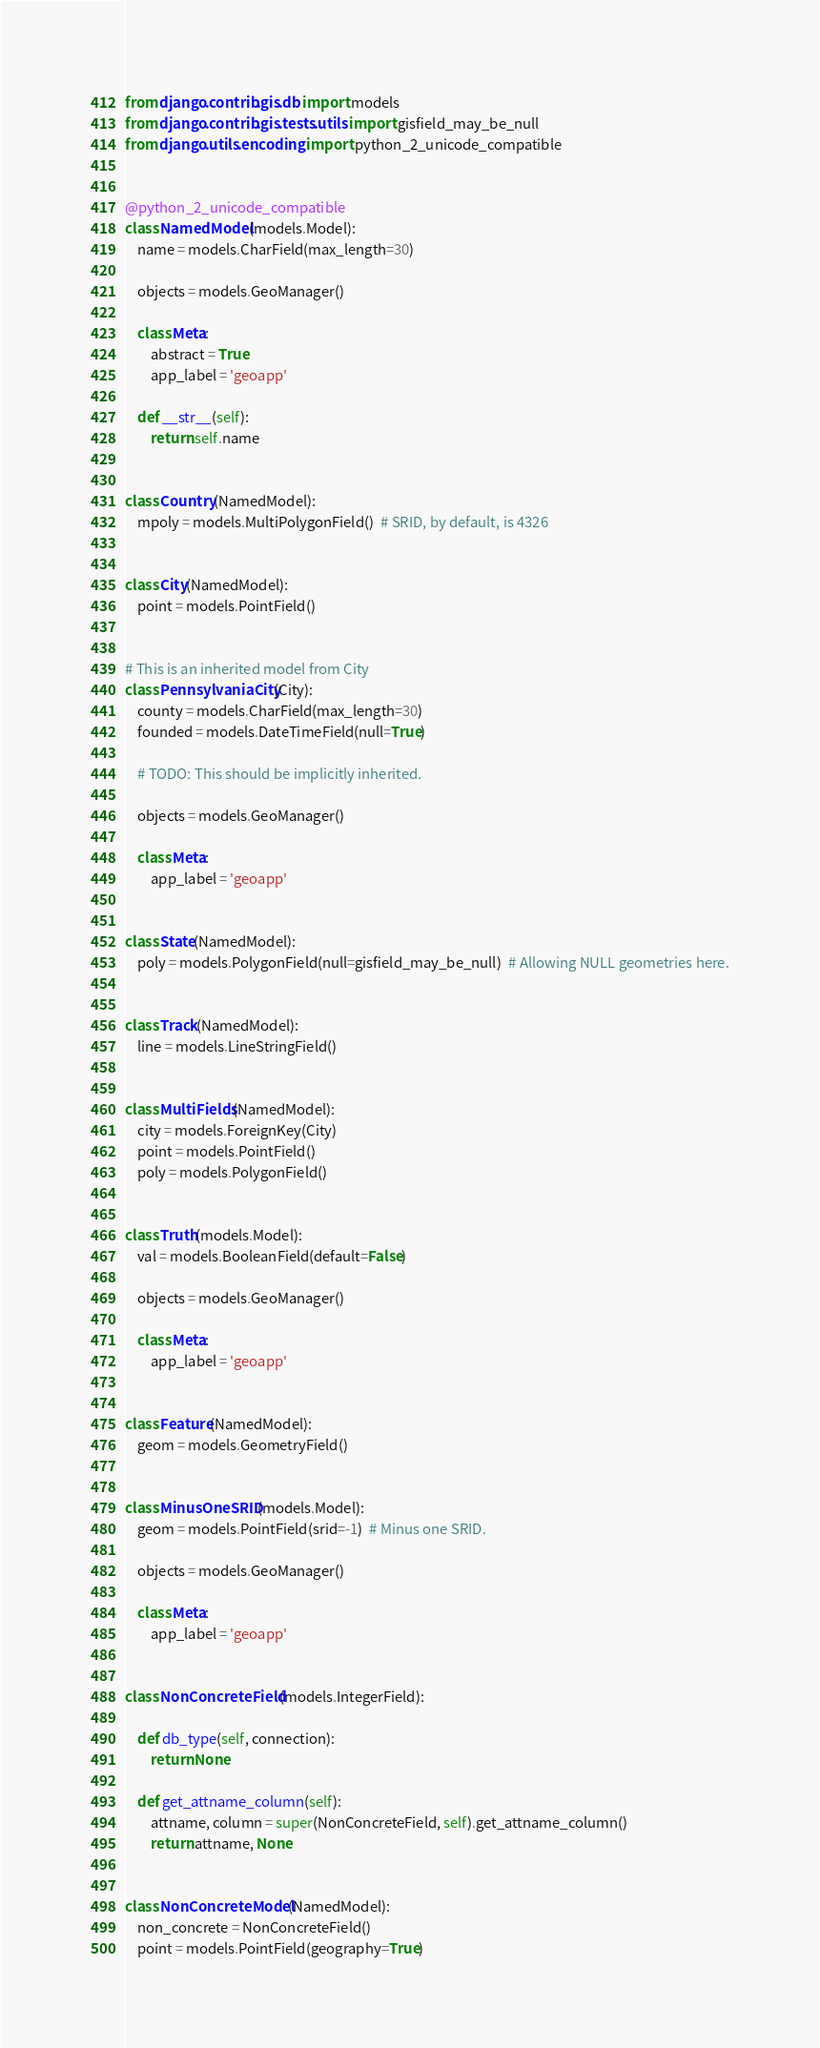<code> <loc_0><loc_0><loc_500><loc_500><_Python_>from django.contrib.gis.db import models
from django.contrib.gis.tests.utils import gisfield_may_be_null
from django.utils.encoding import python_2_unicode_compatible


@python_2_unicode_compatible
class NamedModel(models.Model):
    name = models.CharField(max_length=30)

    objects = models.GeoManager()

    class Meta:
        abstract = True
        app_label = 'geoapp'

    def __str__(self):
        return self.name


class Country(NamedModel):
    mpoly = models.MultiPolygonField()  # SRID, by default, is 4326


class City(NamedModel):
    point = models.PointField()


# This is an inherited model from City
class PennsylvaniaCity(City):
    county = models.CharField(max_length=30)
    founded = models.DateTimeField(null=True)

    # TODO: This should be implicitly inherited.

    objects = models.GeoManager()

    class Meta:
        app_label = 'geoapp'


class State(NamedModel):
    poly = models.PolygonField(null=gisfield_may_be_null)  # Allowing NULL geometries here.


class Track(NamedModel):
    line = models.LineStringField()


class MultiFields(NamedModel):
    city = models.ForeignKey(City)
    point = models.PointField()
    poly = models.PolygonField()


class Truth(models.Model):
    val = models.BooleanField(default=False)

    objects = models.GeoManager()

    class Meta:
        app_label = 'geoapp'


class Feature(NamedModel):
    geom = models.GeometryField()


class MinusOneSRID(models.Model):
    geom = models.PointField(srid=-1)  # Minus one SRID.

    objects = models.GeoManager()

    class Meta:
        app_label = 'geoapp'


class NonConcreteField(models.IntegerField):

    def db_type(self, connection):
        return None

    def get_attname_column(self):
        attname, column = super(NonConcreteField, self).get_attname_column()
        return attname, None


class NonConcreteModel(NamedModel):
    non_concrete = NonConcreteField()
    point = models.PointField(geography=True)
</code> 